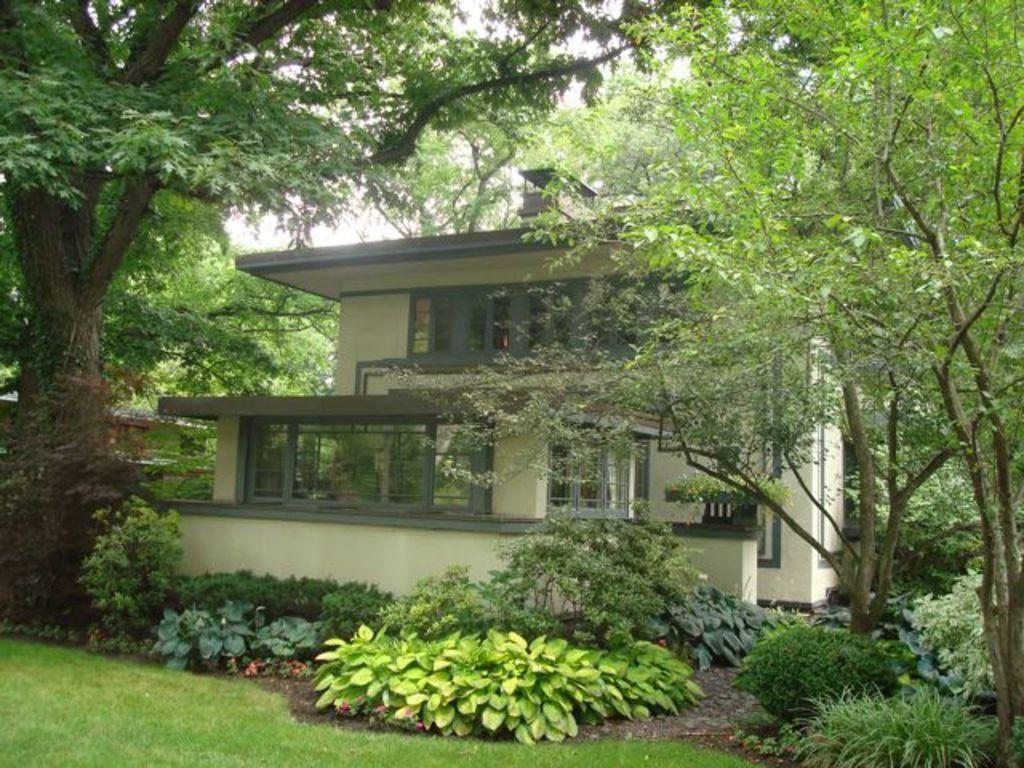Can you describe this image briefly? In this image we can see buildings, shrubs, bushes, trees and sky. 